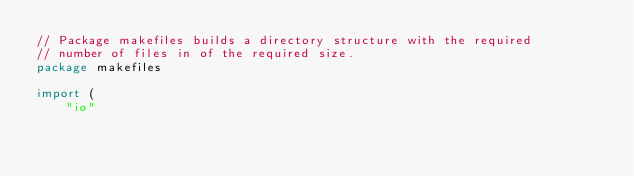<code> <loc_0><loc_0><loc_500><loc_500><_Go_>// Package makefiles builds a directory structure with the required
// number of files in of the required size.
package makefiles

import (
	"io"</code> 